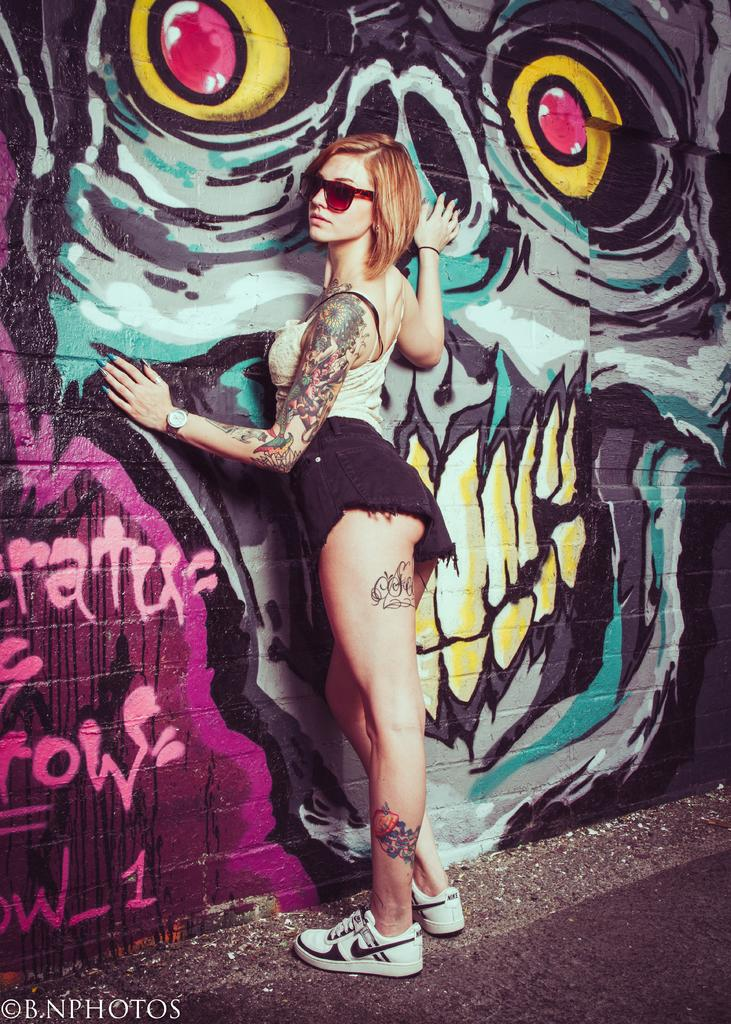Who is present in the image? There is a woman in the picture. What is the woman wearing on her face? The woman is wearing goggles. What is the woman's posture in the image? The woman is standing. What is the nature of the watermark in the image? There is a watermark in the image. Where is the text located in the image? There is text in the bottom left of the image. Can you describe the text visible in the image? There is text visible in the image. Is there any numerical information present in the image? There is a number visible in the image. What type of artwork can be seen in the image? There is a painting on the wall in the image. What type of linen is being used to clean the wrench in the image? There is no linen or wrench present in the image. How much does the quarter cost in the image? There is no quarter present in the image. 